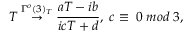Convert formula to latex. <formula><loc_0><loc_0><loc_500><loc_500>T \stackrel { \Gamma ^ { o } ( 3 ) _ { T } } { \rightarrow } \frac { a T - i b } { i c T + d } , \, c \equiv \, 0 \, m o d \, 3 ,</formula> 